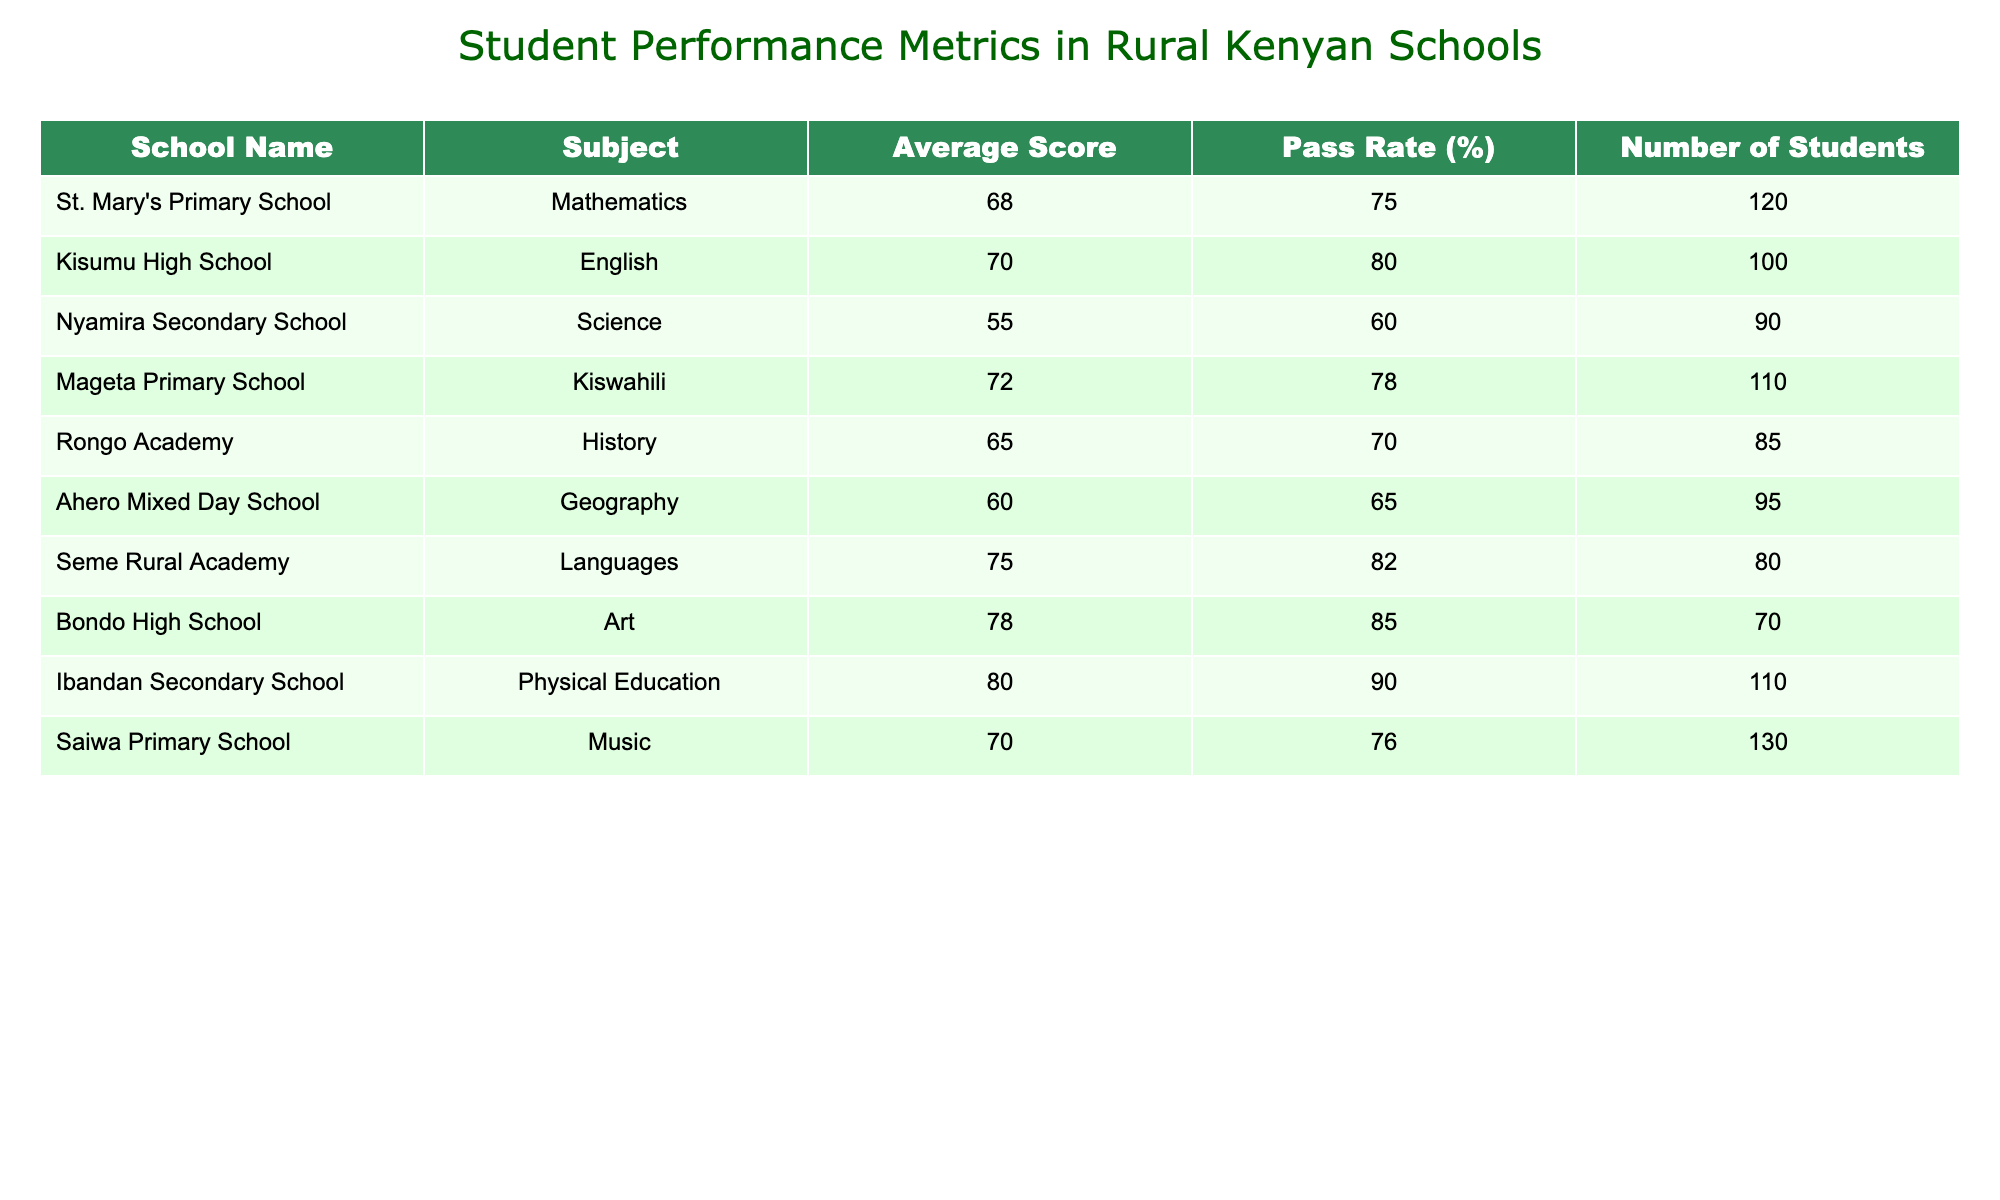What is the average score for Kiswahili at Mageta Primary School? According to the table, the average score for Kiswahili at Mageta Primary School is listed directly in the "Average Score" column next to the school name.
Answer: 72 Which school has the highest pass rate? To find the highest pass rate, we can compare the values listed in the "Pass Rate (%)" column of all the schools. Ibandan Secondary School has the highest pass rate of 90%.
Answer: 90% Is the average score for Physical Education at Ibandan Secondary School greater than 75? From the table, the average score for Physical Education at Ibandan Secondary School is 80, which is indeed greater than 75.
Answer: Yes What is the total number of students across all schools listed? We sum the "Number of Students" for each school: 120 + 100 + 90 + 110 + 85 + 95 + 80 + 70 + 110 + 130 = 1,010.
Answer: 1010 What percentage of the students at Seme Rural Academy passed their language exams? The "Pass Rate (%)" for Seme Rural Academy is given as 82%, indicating that 82% of the 80 students passed their language exams.
Answer: 82% Which subject had the lowest average score among all the schools? By reviewing the "Average Score" column, Science at Nyamira Secondary School had the lowest average score of 55.
Answer: Science (55) How many students failed Mathematics at St. Mary's Primary School? To determine how many failed, we first find the number of students: 120. The pass rate is 75%, implying 25% failed. Therefore, 25% of 120 is 30 students who failed.
Answer: 30 Is the average score for Music at Saiwa Primary School lower than that for History at Rongo Academy? The average score for Music is 70, while History has an average score of 65. Since 70 is higher than 65, the statement is false.
Answer: No What are the pass rates for schools that teach languages? From the table, among the schools that offer language subjects, Seme Rural Academy has a pass rate of 82%, and other schools may include Kiswahili which has a pass rate of 78%. The specific question is to note the scores for those teaching languages.
Answer: 82%, 78% 